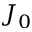Convert formula to latex. <formula><loc_0><loc_0><loc_500><loc_500>J _ { 0 }</formula> 